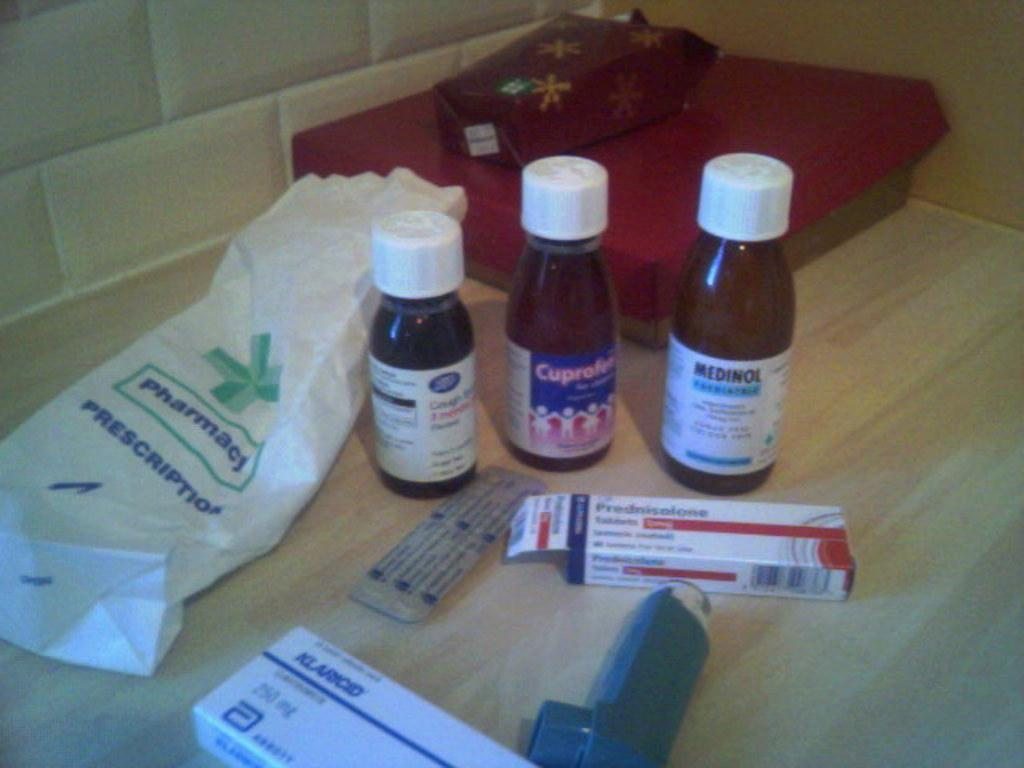<image>
Create a compact narrative representing the image presented. boxes of medicine with one labeled 'klaincid' and bottles standing behind them 